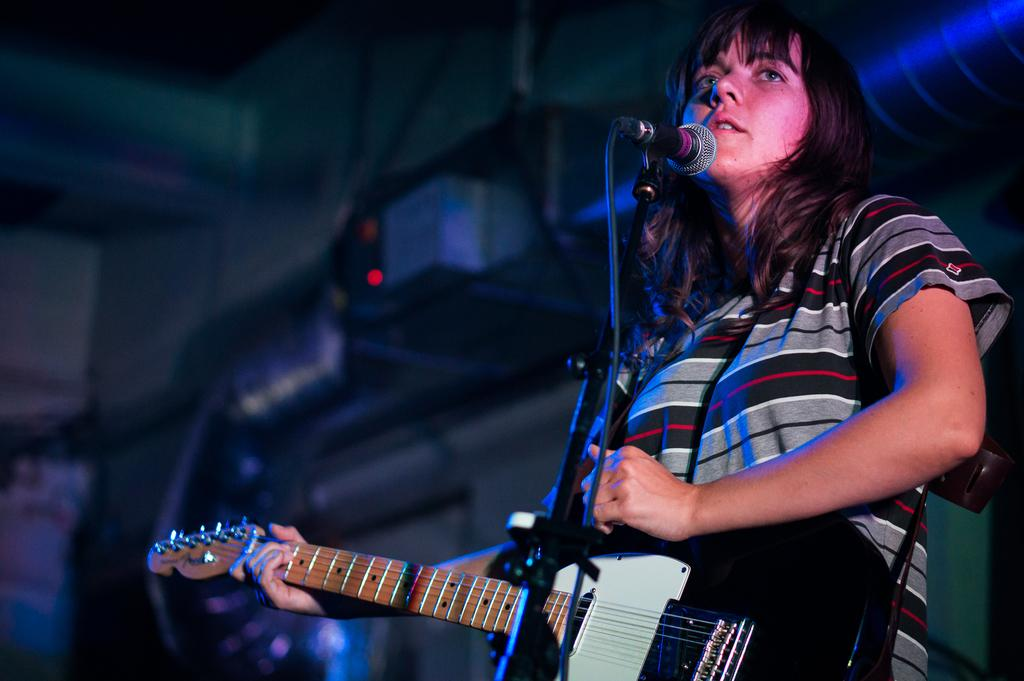Who is the main subject in the image? There is a woman in the image. What is the woman holding in the image? The woman is holding a black guitar. What is the woman doing in the image? The woman is singing. What object is present in the image that is typically used for amplifying sound? There is a microphone in the image. What type of building can be seen in the background of the image? There is no building visible in the image; it primarily features the woman and her musical equipment. 